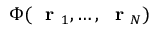Convert formula to latex. <formula><loc_0><loc_0><loc_500><loc_500>\Phi ( r _ { 1 } , \dots , r _ { N } )</formula> 